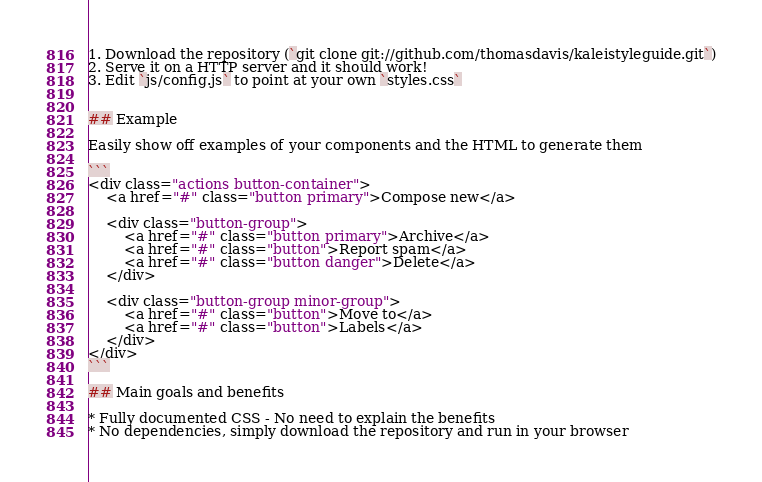<code> <loc_0><loc_0><loc_500><loc_500><_CSS_>
1. Download the repository (`git clone git://github.com/thomasdavis/kaleistyleguide.git`)
2. Serve it on a HTTP server and it should work!
3. Edit `js/config.js` to point at your own `styles.css`


## Example

Easily show off examples of your components and the HTML to generate them

```
<div class="actions button-container">
    <a href="#" class="button primary">Compose new</a>

    <div class="button-group">
        <a href="#" class="button primary">Archive</a>
        <a href="#" class="button">Report spam</a>
        <a href="#" class="button danger">Delete</a>
    </div>

    <div class="button-group minor-group">
        <a href="#" class="button">Move to</a>
        <a href="#" class="button">Labels</a>
    </div>
</div>
```

## Main goals and benefits

* Fully documented CSS - No need to explain the benefits
* No dependencies, simply download the repository and run in your browser</code> 